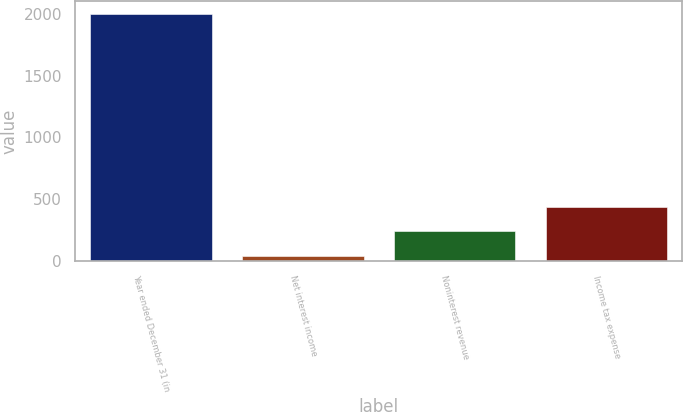Convert chart to OTSL. <chart><loc_0><loc_0><loc_500><loc_500><bar_chart><fcel>Year ended December 31 (in<fcel>Net interest income<fcel>Noninterest revenue<fcel>Income tax expense<nl><fcel>2003<fcel>44<fcel>239.9<fcel>435.8<nl></chart> 